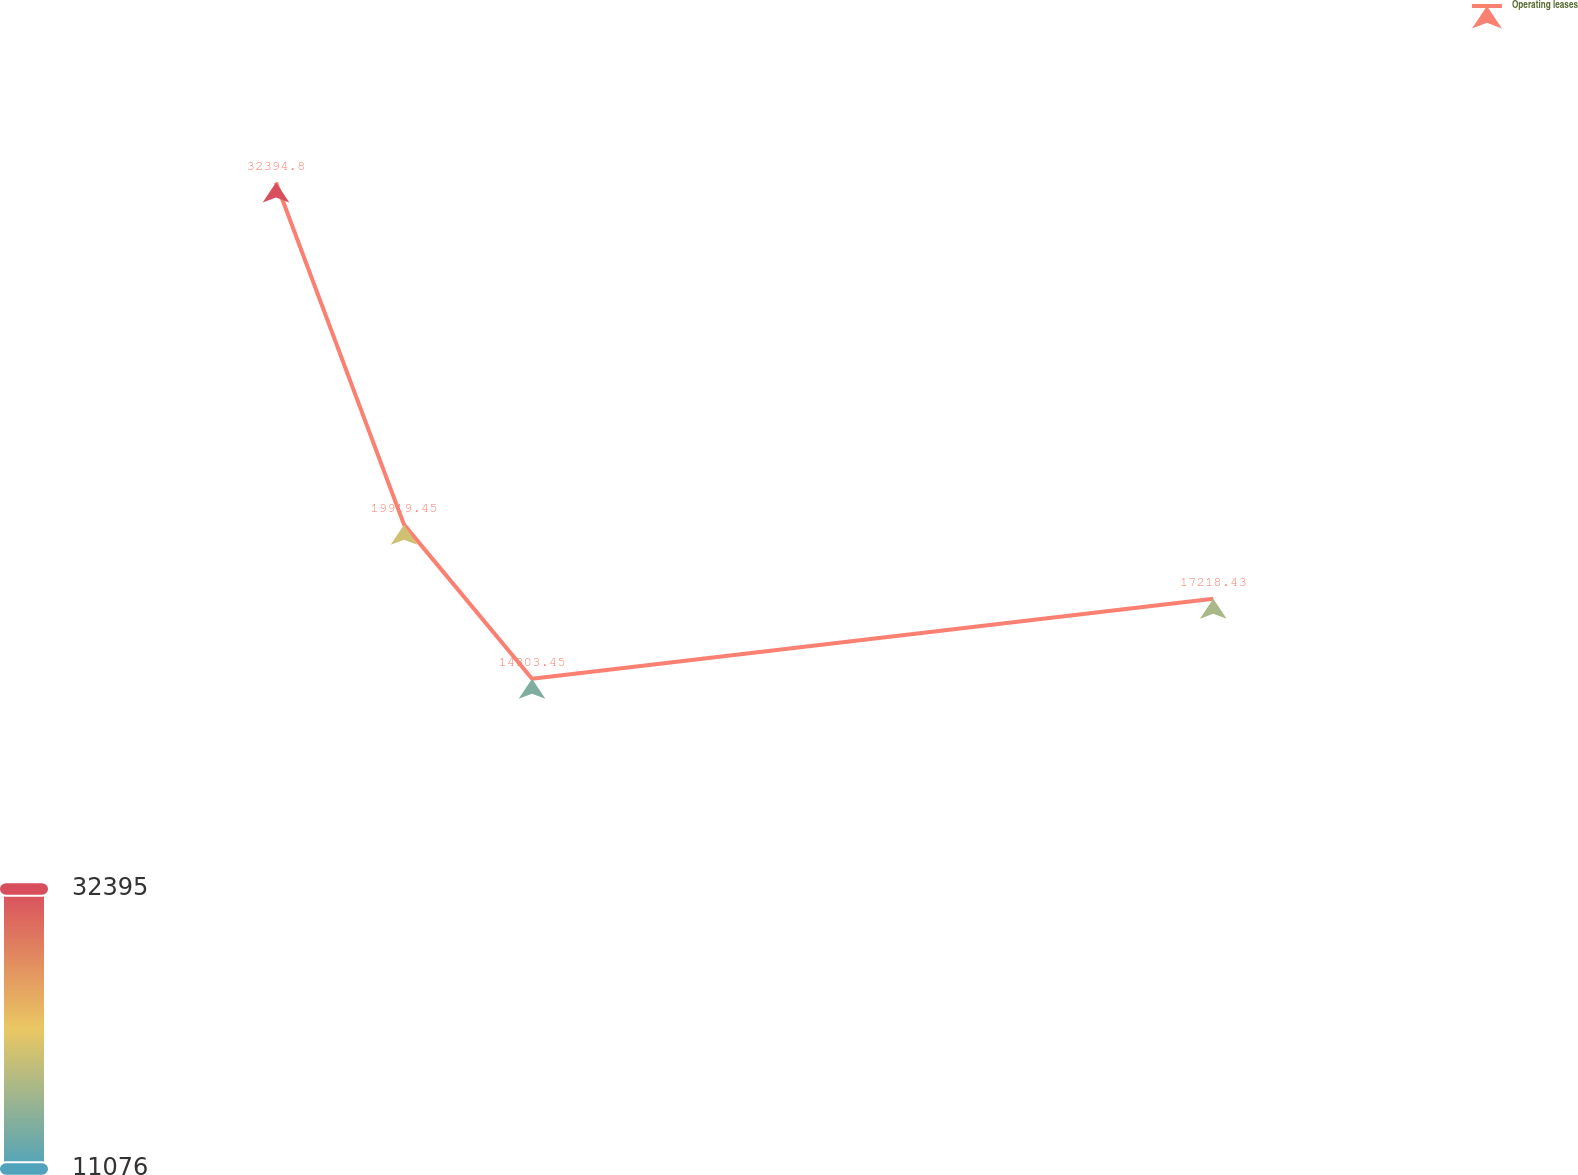Convert chart to OTSL. <chart><loc_0><loc_0><loc_500><loc_500><line_chart><ecel><fcel>Operating leases<nl><fcel>1732.42<fcel>32394.8<nl><fcel>1791.95<fcel>19919.5<nl><fcel>1851.48<fcel>14303.5<nl><fcel>2168.3<fcel>17218.4<nl><fcel>2327.67<fcel>11075.6<nl></chart> 